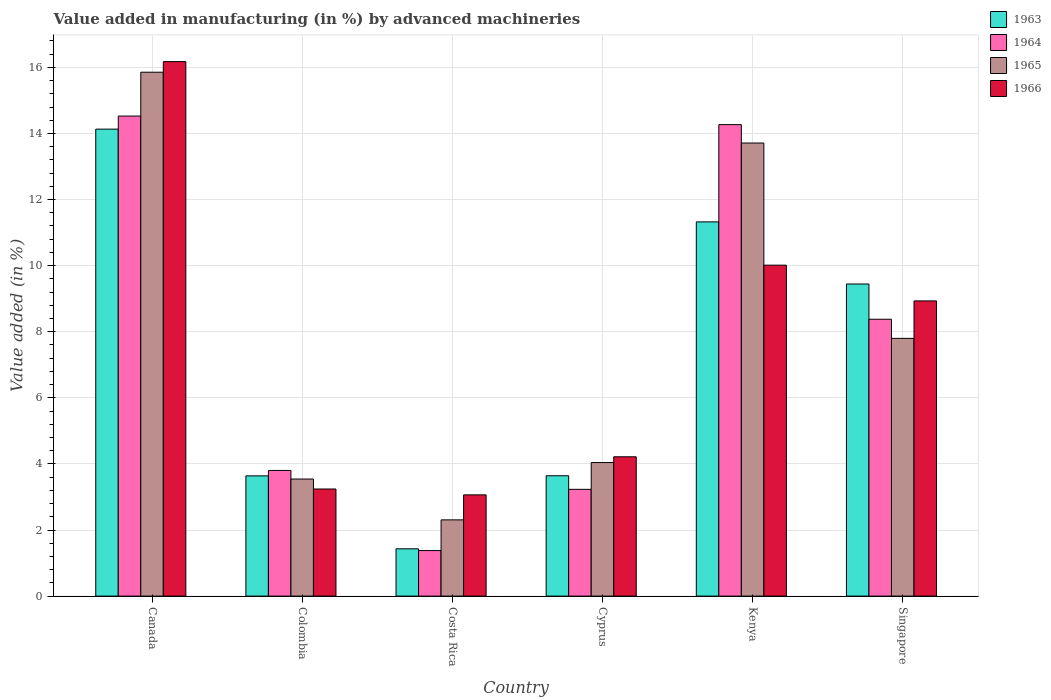How many different coloured bars are there?
Your answer should be compact. 4. How many groups of bars are there?
Your response must be concise. 6. Are the number of bars per tick equal to the number of legend labels?
Make the answer very short. Yes. What is the percentage of value added in manufacturing by advanced machineries in 1966 in Colombia?
Give a very brief answer. 3.24. Across all countries, what is the maximum percentage of value added in manufacturing by advanced machineries in 1964?
Give a very brief answer. 14.53. Across all countries, what is the minimum percentage of value added in manufacturing by advanced machineries in 1966?
Provide a succinct answer. 3.06. In which country was the percentage of value added in manufacturing by advanced machineries in 1963 maximum?
Provide a succinct answer. Canada. In which country was the percentage of value added in manufacturing by advanced machineries in 1965 minimum?
Your response must be concise. Costa Rica. What is the total percentage of value added in manufacturing by advanced machineries in 1965 in the graph?
Your response must be concise. 47.25. What is the difference between the percentage of value added in manufacturing by advanced machineries in 1965 in Canada and that in Singapore?
Make the answer very short. 8.05. What is the difference between the percentage of value added in manufacturing by advanced machineries in 1963 in Canada and the percentage of value added in manufacturing by advanced machineries in 1966 in Costa Rica?
Keep it short and to the point. 11.07. What is the average percentage of value added in manufacturing by advanced machineries in 1963 per country?
Give a very brief answer. 7.27. What is the difference between the percentage of value added in manufacturing by advanced machineries of/in 1964 and percentage of value added in manufacturing by advanced machineries of/in 1963 in Costa Rica?
Your answer should be very brief. -0.05. In how many countries, is the percentage of value added in manufacturing by advanced machineries in 1964 greater than 2.8 %?
Give a very brief answer. 5. What is the ratio of the percentage of value added in manufacturing by advanced machineries in 1964 in Canada to that in Kenya?
Keep it short and to the point. 1.02. Is the difference between the percentage of value added in manufacturing by advanced machineries in 1964 in Colombia and Costa Rica greater than the difference between the percentage of value added in manufacturing by advanced machineries in 1963 in Colombia and Costa Rica?
Your answer should be compact. Yes. What is the difference between the highest and the second highest percentage of value added in manufacturing by advanced machineries in 1963?
Give a very brief answer. -1.88. What is the difference between the highest and the lowest percentage of value added in manufacturing by advanced machineries in 1964?
Your answer should be very brief. 13.15. Is the sum of the percentage of value added in manufacturing by advanced machineries in 1966 in Kenya and Singapore greater than the maximum percentage of value added in manufacturing by advanced machineries in 1963 across all countries?
Keep it short and to the point. Yes. Is it the case that in every country, the sum of the percentage of value added in manufacturing by advanced machineries in 1966 and percentage of value added in manufacturing by advanced machineries in 1965 is greater than the sum of percentage of value added in manufacturing by advanced machineries in 1964 and percentage of value added in manufacturing by advanced machineries in 1963?
Your answer should be compact. Yes. What does the 3rd bar from the left in Canada represents?
Provide a short and direct response. 1965. What does the 2nd bar from the right in Canada represents?
Give a very brief answer. 1965. How many bars are there?
Provide a succinct answer. 24. Are all the bars in the graph horizontal?
Your answer should be compact. No. What is the difference between two consecutive major ticks on the Y-axis?
Give a very brief answer. 2. Does the graph contain any zero values?
Make the answer very short. No. Does the graph contain grids?
Give a very brief answer. Yes. Where does the legend appear in the graph?
Provide a short and direct response. Top right. What is the title of the graph?
Keep it short and to the point. Value added in manufacturing (in %) by advanced machineries. What is the label or title of the Y-axis?
Provide a succinct answer. Value added (in %). What is the Value added (in %) in 1963 in Canada?
Provide a succinct answer. 14.13. What is the Value added (in %) of 1964 in Canada?
Make the answer very short. 14.53. What is the Value added (in %) in 1965 in Canada?
Your answer should be compact. 15.85. What is the Value added (in %) in 1966 in Canada?
Give a very brief answer. 16.17. What is the Value added (in %) of 1963 in Colombia?
Ensure brevity in your answer.  3.64. What is the Value added (in %) in 1964 in Colombia?
Ensure brevity in your answer.  3.8. What is the Value added (in %) of 1965 in Colombia?
Your response must be concise. 3.54. What is the Value added (in %) of 1966 in Colombia?
Offer a terse response. 3.24. What is the Value added (in %) of 1963 in Costa Rica?
Provide a short and direct response. 1.43. What is the Value added (in %) of 1964 in Costa Rica?
Keep it short and to the point. 1.38. What is the Value added (in %) of 1965 in Costa Rica?
Keep it short and to the point. 2.31. What is the Value added (in %) of 1966 in Costa Rica?
Your response must be concise. 3.06. What is the Value added (in %) of 1963 in Cyprus?
Offer a terse response. 3.64. What is the Value added (in %) in 1964 in Cyprus?
Offer a very short reply. 3.23. What is the Value added (in %) of 1965 in Cyprus?
Your answer should be compact. 4.04. What is the Value added (in %) in 1966 in Cyprus?
Keep it short and to the point. 4.22. What is the Value added (in %) of 1963 in Kenya?
Provide a short and direct response. 11.32. What is the Value added (in %) of 1964 in Kenya?
Offer a very short reply. 14.27. What is the Value added (in %) of 1965 in Kenya?
Your answer should be compact. 13.71. What is the Value added (in %) in 1966 in Kenya?
Make the answer very short. 10.01. What is the Value added (in %) of 1963 in Singapore?
Your answer should be very brief. 9.44. What is the Value added (in %) in 1964 in Singapore?
Give a very brief answer. 8.38. What is the Value added (in %) in 1965 in Singapore?
Provide a succinct answer. 7.8. What is the Value added (in %) in 1966 in Singapore?
Offer a terse response. 8.93. Across all countries, what is the maximum Value added (in %) of 1963?
Give a very brief answer. 14.13. Across all countries, what is the maximum Value added (in %) of 1964?
Provide a short and direct response. 14.53. Across all countries, what is the maximum Value added (in %) of 1965?
Give a very brief answer. 15.85. Across all countries, what is the maximum Value added (in %) in 1966?
Keep it short and to the point. 16.17. Across all countries, what is the minimum Value added (in %) in 1963?
Provide a succinct answer. 1.43. Across all countries, what is the minimum Value added (in %) of 1964?
Your answer should be compact. 1.38. Across all countries, what is the minimum Value added (in %) in 1965?
Provide a succinct answer. 2.31. Across all countries, what is the minimum Value added (in %) of 1966?
Your answer should be very brief. 3.06. What is the total Value added (in %) in 1963 in the graph?
Give a very brief answer. 43.61. What is the total Value added (in %) of 1964 in the graph?
Give a very brief answer. 45.58. What is the total Value added (in %) in 1965 in the graph?
Ensure brevity in your answer.  47.25. What is the total Value added (in %) in 1966 in the graph?
Make the answer very short. 45.64. What is the difference between the Value added (in %) of 1963 in Canada and that in Colombia?
Keep it short and to the point. 10.49. What is the difference between the Value added (in %) of 1964 in Canada and that in Colombia?
Ensure brevity in your answer.  10.72. What is the difference between the Value added (in %) of 1965 in Canada and that in Colombia?
Give a very brief answer. 12.31. What is the difference between the Value added (in %) of 1966 in Canada and that in Colombia?
Ensure brevity in your answer.  12.93. What is the difference between the Value added (in %) of 1963 in Canada and that in Costa Rica?
Make the answer very short. 12.7. What is the difference between the Value added (in %) in 1964 in Canada and that in Costa Rica?
Make the answer very short. 13.15. What is the difference between the Value added (in %) of 1965 in Canada and that in Costa Rica?
Provide a short and direct response. 13.55. What is the difference between the Value added (in %) of 1966 in Canada and that in Costa Rica?
Your answer should be compact. 13.11. What is the difference between the Value added (in %) in 1963 in Canada and that in Cyprus?
Keep it short and to the point. 10.49. What is the difference between the Value added (in %) in 1964 in Canada and that in Cyprus?
Your answer should be compact. 11.3. What is the difference between the Value added (in %) of 1965 in Canada and that in Cyprus?
Keep it short and to the point. 11.81. What is the difference between the Value added (in %) of 1966 in Canada and that in Cyprus?
Give a very brief answer. 11.96. What is the difference between the Value added (in %) in 1963 in Canada and that in Kenya?
Your answer should be compact. 2.81. What is the difference between the Value added (in %) of 1964 in Canada and that in Kenya?
Your answer should be compact. 0.26. What is the difference between the Value added (in %) of 1965 in Canada and that in Kenya?
Offer a terse response. 2.14. What is the difference between the Value added (in %) in 1966 in Canada and that in Kenya?
Give a very brief answer. 6.16. What is the difference between the Value added (in %) in 1963 in Canada and that in Singapore?
Keep it short and to the point. 4.69. What is the difference between the Value added (in %) in 1964 in Canada and that in Singapore?
Your answer should be very brief. 6.15. What is the difference between the Value added (in %) of 1965 in Canada and that in Singapore?
Offer a very short reply. 8.05. What is the difference between the Value added (in %) in 1966 in Canada and that in Singapore?
Provide a short and direct response. 7.24. What is the difference between the Value added (in %) of 1963 in Colombia and that in Costa Rica?
Keep it short and to the point. 2.21. What is the difference between the Value added (in %) in 1964 in Colombia and that in Costa Rica?
Offer a very short reply. 2.42. What is the difference between the Value added (in %) in 1965 in Colombia and that in Costa Rica?
Give a very brief answer. 1.24. What is the difference between the Value added (in %) in 1966 in Colombia and that in Costa Rica?
Provide a succinct answer. 0.18. What is the difference between the Value added (in %) in 1963 in Colombia and that in Cyprus?
Give a very brief answer. -0. What is the difference between the Value added (in %) in 1964 in Colombia and that in Cyprus?
Your answer should be very brief. 0.57. What is the difference between the Value added (in %) of 1965 in Colombia and that in Cyprus?
Ensure brevity in your answer.  -0.5. What is the difference between the Value added (in %) of 1966 in Colombia and that in Cyprus?
Ensure brevity in your answer.  -0.97. What is the difference between the Value added (in %) in 1963 in Colombia and that in Kenya?
Offer a very short reply. -7.69. What is the difference between the Value added (in %) of 1964 in Colombia and that in Kenya?
Your answer should be very brief. -10.47. What is the difference between the Value added (in %) in 1965 in Colombia and that in Kenya?
Your answer should be compact. -10.17. What is the difference between the Value added (in %) in 1966 in Colombia and that in Kenya?
Make the answer very short. -6.77. What is the difference between the Value added (in %) in 1963 in Colombia and that in Singapore?
Keep it short and to the point. -5.81. What is the difference between the Value added (in %) of 1964 in Colombia and that in Singapore?
Make the answer very short. -4.58. What is the difference between the Value added (in %) in 1965 in Colombia and that in Singapore?
Give a very brief answer. -4.26. What is the difference between the Value added (in %) of 1966 in Colombia and that in Singapore?
Keep it short and to the point. -5.69. What is the difference between the Value added (in %) in 1963 in Costa Rica and that in Cyprus?
Offer a terse response. -2.21. What is the difference between the Value added (in %) of 1964 in Costa Rica and that in Cyprus?
Provide a succinct answer. -1.85. What is the difference between the Value added (in %) of 1965 in Costa Rica and that in Cyprus?
Your answer should be very brief. -1.73. What is the difference between the Value added (in %) in 1966 in Costa Rica and that in Cyprus?
Your response must be concise. -1.15. What is the difference between the Value added (in %) of 1963 in Costa Rica and that in Kenya?
Give a very brief answer. -9.89. What is the difference between the Value added (in %) in 1964 in Costa Rica and that in Kenya?
Keep it short and to the point. -12.89. What is the difference between the Value added (in %) of 1965 in Costa Rica and that in Kenya?
Your response must be concise. -11.4. What is the difference between the Value added (in %) in 1966 in Costa Rica and that in Kenya?
Provide a succinct answer. -6.95. What is the difference between the Value added (in %) of 1963 in Costa Rica and that in Singapore?
Keep it short and to the point. -8.01. What is the difference between the Value added (in %) of 1964 in Costa Rica and that in Singapore?
Your answer should be compact. -7. What is the difference between the Value added (in %) of 1965 in Costa Rica and that in Singapore?
Provide a succinct answer. -5.49. What is the difference between the Value added (in %) in 1966 in Costa Rica and that in Singapore?
Provide a short and direct response. -5.87. What is the difference between the Value added (in %) of 1963 in Cyprus and that in Kenya?
Your answer should be very brief. -7.68. What is the difference between the Value added (in %) of 1964 in Cyprus and that in Kenya?
Ensure brevity in your answer.  -11.04. What is the difference between the Value added (in %) of 1965 in Cyprus and that in Kenya?
Ensure brevity in your answer.  -9.67. What is the difference between the Value added (in %) of 1966 in Cyprus and that in Kenya?
Offer a terse response. -5.8. What is the difference between the Value added (in %) of 1963 in Cyprus and that in Singapore?
Keep it short and to the point. -5.8. What is the difference between the Value added (in %) of 1964 in Cyprus and that in Singapore?
Your answer should be very brief. -5.15. What is the difference between the Value added (in %) in 1965 in Cyprus and that in Singapore?
Make the answer very short. -3.76. What is the difference between the Value added (in %) of 1966 in Cyprus and that in Singapore?
Keep it short and to the point. -4.72. What is the difference between the Value added (in %) of 1963 in Kenya and that in Singapore?
Offer a terse response. 1.88. What is the difference between the Value added (in %) of 1964 in Kenya and that in Singapore?
Keep it short and to the point. 5.89. What is the difference between the Value added (in %) in 1965 in Kenya and that in Singapore?
Your response must be concise. 5.91. What is the difference between the Value added (in %) in 1966 in Kenya and that in Singapore?
Offer a terse response. 1.08. What is the difference between the Value added (in %) in 1963 in Canada and the Value added (in %) in 1964 in Colombia?
Your response must be concise. 10.33. What is the difference between the Value added (in %) of 1963 in Canada and the Value added (in %) of 1965 in Colombia?
Your response must be concise. 10.59. What is the difference between the Value added (in %) in 1963 in Canada and the Value added (in %) in 1966 in Colombia?
Ensure brevity in your answer.  10.89. What is the difference between the Value added (in %) of 1964 in Canada and the Value added (in %) of 1965 in Colombia?
Ensure brevity in your answer.  10.98. What is the difference between the Value added (in %) in 1964 in Canada and the Value added (in %) in 1966 in Colombia?
Provide a succinct answer. 11.29. What is the difference between the Value added (in %) of 1965 in Canada and the Value added (in %) of 1966 in Colombia?
Make the answer very short. 12.61. What is the difference between the Value added (in %) of 1963 in Canada and the Value added (in %) of 1964 in Costa Rica?
Ensure brevity in your answer.  12.75. What is the difference between the Value added (in %) in 1963 in Canada and the Value added (in %) in 1965 in Costa Rica?
Ensure brevity in your answer.  11.82. What is the difference between the Value added (in %) in 1963 in Canada and the Value added (in %) in 1966 in Costa Rica?
Your answer should be compact. 11.07. What is the difference between the Value added (in %) of 1964 in Canada and the Value added (in %) of 1965 in Costa Rica?
Your answer should be very brief. 12.22. What is the difference between the Value added (in %) in 1964 in Canada and the Value added (in %) in 1966 in Costa Rica?
Make the answer very short. 11.46. What is the difference between the Value added (in %) in 1965 in Canada and the Value added (in %) in 1966 in Costa Rica?
Keep it short and to the point. 12.79. What is the difference between the Value added (in %) in 1963 in Canada and the Value added (in %) in 1964 in Cyprus?
Ensure brevity in your answer.  10.9. What is the difference between the Value added (in %) in 1963 in Canada and the Value added (in %) in 1965 in Cyprus?
Give a very brief answer. 10.09. What is the difference between the Value added (in %) in 1963 in Canada and the Value added (in %) in 1966 in Cyprus?
Your answer should be very brief. 9.92. What is the difference between the Value added (in %) in 1964 in Canada and the Value added (in %) in 1965 in Cyprus?
Give a very brief answer. 10.49. What is the difference between the Value added (in %) of 1964 in Canada and the Value added (in %) of 1966 in Cyprus?
Your answer should be compact. 10.31. What is the difference between the Value added (in %) in 1965 in Canada and the Value added (in %) in 1966 in Cyprus?
Offer a terse response. 11.64. What is the difference between the Value added (in %) in 1963 in Canada and the Value added (in %) in 1964 in Kenya?
Your response must be concise. -0.14. What is the difference between the Value added (in %) of 1963 in Canada and the Value added (in %) of 1965 in Kenya?
Your answer should be very brief. 0.42. What is the difference between the Value added (in %) of 1963 in Canada and the Value added (in %) of 1966 in Kenya?
Provide a short and direct response. 4.12. What is the difference between the Value added (in %) in 1964 in Canada and the Value added (in %) in 1965 in Kenya?
Provide a short and direct response. 0.82. What is the difference between the Value added (in %) in 1964 in Canada and the Value added (in %) in 1966 in Kenya?
Your response must be concise. 4.51. What is the difference between the Value added (in %) of 1965 in Canada and the Value added (in %) of 1966 in Kenya?
Offer a very short reply. 5.84. What is the difference between the Value added (in %) in 1963 in Canada and the Value added (in %) in 1964 in Singapore?
Your answer should be very brief. 5.75. What is the difference between the Value added (in %) in 1963 in Canada and the Value added (in %) in 1965 in Singapore?
Offer a very short reply. 6.33. What is the difference between the Value added (in %) in 1963 in Canada and the Value added (in %) in 1966 in Singapore?
Provide a succinct answer. 5.2. What is the difference between the Value added (in %) of 1964 in Canada and the Value added (in %) of 1965 in Singapore?
Make the answer very short. 6.73. What is the difference between the Value added (in %) of 1964 in Canada and the Value added (in %) of 1966 in Singapore?
Provide a succinct answer. 5.59. What is the difference between the Value added (in %) in 1965 in Canada and the Value added (in %) in 1966 in Singapore?
Offer a terse response. 6.92. What is the difference between the Value added (in %) in 1963 in Colombia and the Value added (in %) in 1964 in Costa Rica?
Your answer should be compact. 2.26. What is the difference between the Value added (in %) of 1963 in Colombia and the Value added (in %) of 1965 in Costa Rica?
Your answer should be very brief. 1.33. What is the difference between the Value added (in %) in 1963 in Colombia and the Value added (in %) in 1966 in Costa Rica?
Your answer should be compact. 0.57. What is the difference between the Value added (in %) of 1964 in Colombia and the Value added (in %) of 1965 in Costa Rica?
Ensure brevity in your answer.  1.49. What is the difference between the Value added (in %) of 1964 in Colombia and the Value added (in %) of 1966 in Costa Rica?
Keep it short and to the point. 0.74. What is the difference between the Value added (in %) of 1965 in Colombia and the Value added (in %) of 1966 in Costa Rica?
Your answer should be very brief. 0.48. What is the difference between the Value added (in %) in 1963 in Colombia and the Value added (in %) in 1964 in Cyprus?
Offer a terse response. 0.41. What is the difference between the Value added (in %) of 1963 in Colombia and the Value added (in %) of 1965 in Cyprus?
Give a very brief answer. -0.4. What is the difference between the Value added (in %) of 1963 in Colombia and the Value added (in %) of 1966 in Cyprus?
Your response must be concise. -0.58. What is the difference between the Value added (in %) in 1964 in Colombia and the Value added (in %) in 1965 in Cyprus?
Give a very brief answer. -0.24. What is the difference between the Value added (in %) of 1964 in Colombia and the Value added (in %) of 1966 in Cyprus?
Offer a terse response. -0.41. What is the difference between the Value added (in %) of 1965 in Colombia and the Value added (in %) of 1966 in Cyprus?
Offer a very short reply. -0.67. What is the difference between the Value added (in %) of 1963 in Colombia and the Value added (in %) of 1964 in Kenya?
Keep it short and to the point. -10.63. What is the difference between the Value added (in %) in 1963 in Colombia and the Value added (in %) in 1965 in Kenya?
Make the answer very short. -10.07. What is the difference between the Value added (in %) in 1963 in Colombia and the Value added (in %) in 1966 in Kenya?
Provide a succinct answer. -6.38. What is the difference between the Value added (in %) in 1964 in Colombia and the Value added (in %) in 1965 in Kenya?
Your answer should be compact. -9.91. What is the difference between the Value added (in %) in 1964 in Colombia and the Value added (in %) in 1966 in Kenya?
Offer a terse response. -6.21. What is the difference between the Value added (in %) in 1965 in Colombia and the Value added (in %) in 1966 in Kenya?
Make the answer very short. -6.47. What is the difference between the Value added (in %) of 1963 in Colombia and the Value added (in %) of 1964 in Singapore?
Your answer should be compact. -4.74. What is the difference between the Value added (in %) in 1963 in Colombia and the Value added (in %) in 1965 in Singapore?
Make the answer very short. -4.16. What is the difference between the Value added (in %) in 1963 in Colombia and the Value added (in %) in 1966 in Singapore?
Make the answer very short. -5.29. What is the difference between the Value added (in %) in 1964 in Colombia and the Value added (in %) in 1965 in Singapore?
Offer a terse response. -4. What is the difference between the Value added (in %) of 1964 in Colombia and the Value added (in %) of 1966 in Singapore?
Provide a succinct answer. -5.13. What is the difference between the Value added (in %) of 1965 in Colombia and the Value added (in %) of 1966 in Singapore?
Keep it short and to the point. -5.39. What is the difference between the Value added (in %) in 1963 in Costa Rica and the Value added (in %) in 1964 in Cyprus?
Provide a succinct answer. -1.8. What is the difference between the Value added (in %) of 1963 in Costa Rica and the Value added (in %) of 1965 in Cyprus?
Offer a very short reply. -2.61. What is the difference between the Value added (in %) in 1963 in Costa Rica and the Value added (in %) in 1966 in Cyprus?
Make the answer very short. -2.78. What is the difference between the Value added (in %) of 1964 in Costa Rica and the Value added (in %) of 1965 in Cyprus?
Offer a very short reply. -2.66. What is the difference between the Value added (in %) of 1964 in Costa Rica and the Value added (in %) of 1966 in Cyprus?
Provide a short and direct response. -2.84. What is the difference between the Value added (in %) of 1965 in Costa Rica and the Value added (in %) of 1966 in Cyprus?
Offer a terse response. -1.91. What is the difference between the Value added (in %) of 1963 in Costa Rica and the Value added (in %) of 1964 in Kenya?
Make the answer very short. -12.84. What is the difference between the Value added (in %) of 1963 in Costa Rica and the Value added (in %) of 1965 in Kenya?
Your answer should be compact. -12.28. What is the difference between the Value added (in %) of 1963 in Costa Rica and the Value added (in %) of 1966 in Kenya?
Your answer should be very brief. -8.58. What is the difference between the Value added (in %) in 1964 in Costa Rica and the Value added (in %) in 1965 in Kenya?
Give a very brief answer. -12.33. What is the difference between the Value added (in %) in 1964 in Costa Rica and the Value added (in %) in 1966 in Kenya?
Ensure brevity in your answer.  -8.64. What is the difference between the Value added (in %) of 1965 in Costa Rica and the Value added (in %) of 1966 in Kenya?
Your answer should be compact. -7.71. What is the difference between the Value added (in %) of 1963 in Costa Rica and the Value added (in %) of 1964 in Singapore?
Provide a succinct answer. -6.95. What is the difference between the Value added (in %) in 1963 in Costa Rica and the Value added (in %) in 1965 in Singapore?
Your answer should be very brief. -6.37. What is the difference between the Value added (in %) of 1963 in Costa Rica and the Value added (in %) of 1966 in Singapore?
Offer a terse response. -7.5. What is the difference between the Value added (in %) in 1964 in Costa Rica and the Value added (in %) in 1965 in Singapore?
Your response must be concise. -6.42. What is the difference between the Value added (in %) in 1964 in Costa Rica and the Value added (in %) in 1966 in Singapore?
Give a very brief answer. -7.55. What is the difference between the Value added (in %) of 1965 in Costa Rica and the Value added (in %) of 1966 in Singapore?
Provide a short and direct response. -6.63. What is the difference between the Value added (in %) in 1963 in Cyprus and the Value added (in %) in 1964 in Kenya?
Keep it short and to the point. -10.63. What is the difference between the Value added (in %) of 1963 in Cyprus and the Value added (in %) of 1965 in Kenya?
Ensure brevity in your answer.  -10.07. What is the difference between the Value added (in %) of 1963 in Cyprus and the Value added (in %) of 1966 in Kenya?
Your answer should be compact. -6.37. What is the difference between the Value added (in %) of 1964 in Cyprus and the Value added (in %) of 1965 in Kenya?
Provide a short and direct response. -10.48. What is the difference between the Value added (in %) in 1964 in Cyprus and the Value added (in %) in 1966 in Kenya?
Provide a short and direct response. -6.78. What is the difference between the Value added (in %) in 1965 in Cyprus and the Value added (in %) in 1966 in Kenya?
Keep it short and to the point. -5.97. What is the difference between the Value added (in %) of 1963 in Cyprus and the Value added (in %) of 1964 in Singapore?
Provide a succinct answer. -4.74. What is the difference between the Value added (in %) of 1963 in Cyprus and the Value added (in %) of 1965 in Singapore?
Offer a very short reply. -4.16. What is the difference between the Value added (in %) in 1963 in Cyprus and the Value added (in %) in 1966 in Singapore?
Give a very brief answer. -5.29. What is the difference between the Value added (in %) of 1964 in Cyprus and the Value added (in %) of 1965 in Singapore?
Ensure brevity in your answer.  -4.57. What is the difference between the Value added (in %) of 1964 in Cyprus and the Value added (in %) of 1966 in Singapore?
Your response must be concise. -5.7. What is the difference between the Value added (in %) in 1965 in Cyprus and the Value added (in %) in 1966 in Singapore?
Keep it short and to the point. -4.89. What is the difference between the Value added (in %) in 1963 in Kenya and the Value added (in %) in 1964 in Singapore?
Ensure brevity in your answer.  2.95. What is the difference between the Value added (in %) of 1963 in Kenya and the Value added (in %) of 1965 in Singapore?
Offer a terse response. 3.52. What is the difference between the Value added (in %) in 1963 in Kenya and the Value added (in %) in 1966 in Singapore?
Offer a very short reply. 2.39. What is the difference between the Value added (in %) in 1964 in Kenya and the Value added (in %) in 1965 in Singapore?
Keep it short and to the point. 6.47. What is the difference between the Value added (in %) of 1964 in Kenya and the Value added (in %) of 1966 in Singapore?
Your response must be concise. 5.33. What is the difference between the Value added (in %) of 1965 in Kenya and the Value added (in %) of 1966 in Singapore?
Make the answer very short. 4.78. What is the average Value added (in %) in 1963 per country?
Keep it short and to the point. 7.27. What is the average Value added (in %) of 1964 per country?
Give a very brief answer. 7.6. What is the average Value added (in %) in 1965 per country?
Provide a succinct answer. 7.88. What is the average Value added (in %) in 1966 per country?
Provide a succinct answer. 7.61. What is the difference between the Value added (in %) of 1963 and Value added (in %) of 1964 in Canada?
Give a very brief answer. -0.4. What is the difference between the Value added (in %) in 1963 and Value added (in %) in 1965 in Canada?
Offer a very short reply. -1.72. What is the difference between the Value added (in %) in 1963 and Value added (in %) in 1966 in Canada?
Make the answer very short. -2.04. What is the difference between the Value added (in %) of 1964 and Value added (in %) of 1965 in Canada?
Offer a very short reply. -1.33. What is the difference between the Value added (in %) of 1964 and Value added (in %) of 1966 in Canada?
Ensure brevity in your answer.  -1.65. What is the difference between the Value added (in %) of 1965 and Value added (in %) of 1966 in Canada?
Ensure brevity in your answer.  -0.32. What is the difference between the Value added (in %) in 1963 and Value added (in %) in 1964 in Colombia?
Your answer should be very brief. -0.16. What is the difference between the Value added (in %) in 1963 and Value added (in %) in 1965 in Colombia?
Give a very brief answer. 0.1. What is the difference between the Value added (in %) in 1963 and Value added (in %) in 1966 in Colombia?
Your response must be concise. 0.4. What is the difference between the Value added (in %) of 1964 and Value added (in %) of 1965 in Colombia?
Provide a succinct answer. 0.26. What is the difference between the Value added (in %) in 1964 and Value added (in %) in 1966 in Colombia?
Your response must be concise. 0.56. What is the difference between the Value added (in %) in 1965 and Value added (in %) in 1966 in Colombia?
Your answer should be compact. 0.3. What is the difference between the Value added (in %) in 1963 and Value added (in %) in 1964 in Costa Rica?
Make the answer very short. 0.05. What is the difference between the Value added (in %) in 1963 and Value added (in %) in 1965 in Costa Rica?
Offer a very short reply. -0.88. What is the difference between the Value added (in %) of 1963 and Value added (in %) of 1966 in Costa Rica?
Provide a short and direct response. -1.63. What is the difference between the Value added (in %) in 1964 and Value added (in %) in 1965 in Costa Rica?
Your answer should be very brief. -0.93. What is the difference between the Value added (in %) in 1964 and Value added (in %) in 1966 in Costa Rica?
Give a very brief answer. -1.69. What is the difference between the Value added (in %) of 1965 and Value added (in %) of 1966 in Costa Rica?
Your answer should be very brief. -0.76. What is the difference between the Value added (in %) of 1963 and Value added (in %) of 1964 in Cyprus?
Offer a very short reply. 0.41. What is the difference between the Value added (in %) of 1963 and Value added (in %) of 1965 in Cyprus?
Your answer should be very brief. -0.4. What is the difference between the Value added (in %) of 1963 and Value added (in %) of 1966 in Cyprus?
Give a very brief answer. -0.57. What is the difference between the Value added (in %) in 1964 and Value added (in %) in 1965 in Cyprus?
Offer a very short reply. -0.81. What is the difference between the Value added (in %) in 1964 and Value added (in %) in 1966 in Cyprus?
Offer a terse response. -0.98. What is the difference between the Value added (in %) of 1965 and Value added (in %) of 1966 in Cyprus?
Offer a terse response. -0.17. What is the difference between the Value added (in %) in 1963 and Value added (in %) in 1964 in Kenya?
Provide a short and direct response. -2.94. What is the difference between the Value added (in %) of 1963 and Value added (in %) of 1965 in Kenya?
Ensure brevity in your answer.  -2.39. What is the difference between the Value added (in %) in 1963 and Value added (in %) in 1966 in Kenya?
Keep it short and to the point. 1.31. What is the difference between the Value added (in %) in 1964 and Value added (in %) in 1965 in Kenya?
Give a very brief answer. 0.56. What is the difference between the Value added (in %) in 1964 and Value added (in %) in 1966 in Kenya?
Make the answer very short. 4.25. What is the difference between the Value added (in %) of 1965 and Value added (in %) of 1966 in Kenya?
Provide a short and direct response. 3.7. What is the difference between the Value added (in %) of 1963 and Value added (in %) of 1964 in Singapore?
Ensure brevity in your answer.  1.07. What is the difference between the Value added (in %) of 1963 and Value added (in %) of 1965 in Singapore?
Ensure brevity in your answer.  1.64. What is the difference between the Value added (in %) of 1963 and Value added (in %) of 1966 in Singapore?
Your response must be concise. 0.51. What is the difference between the Value added (in %) of 1964 and Value added (in %) of 1965 in Singapore?
Provide a succinct answer. 0.58. What is the difference between the Value added (in %) in 1964 and Value added (in %) in 1966 in Singapore?
Your answer should be compact. -0.55. What is the difference between the Value added (in %) of 1965 and Value added (in %) of 1966 in Singapore?
Provide a succinct answer. -1.13. What is the ratio of the Value added (in %) in 1963 in Canada to that in Colombia?
Your response must be concise. 3.88. What is the ratio of the Value added (in %) in 1964 in Canada to that in Colombia?
Ensure brevity in your answer.  3.82. What is the ratio of the Value added (in %) of 1965 in Canada to that in Colombia?
Offer a very short reply. 4.48. What is the ratio of the Value added (in %) in 1966 in Canada to that in Colombia?
Provide a succinct answer. 4.99. What is the ratio of the Value added (in %) of 1963 in Canada to that in Costa Rica?
Your answer should be very brief. 9.87. What is the ratio of the Value added (in %) in 1964 in Canada to that in Costa Rica?
Offer a very short reply. 10.54. What is the ratio of the Value added (in %) of 1965 in Canada to that in Costa Rica?
Give a very brief answer. 6.87. What is the ratio of the Value added (in %) of 1966 in Canada to that in Costa Rica?
Your answer should be very brief. 5.28. What is the ratio of the Value added (in %) of 1963 in Canada to that in Cyprus?
Offer a very short reply. 3.88. What is the ratio of the Value added (in %) in 1964 in Canada to that in Cyprus?
Provide a succinct answer. 4.5. What is the ratio of the Value added (in %) in 1965 in Canada to that in Cyprus?
Keep it short and to the point. 3.92. What is the ratio of the Value added (in %) of 1966 in Canada to that in Cyprus?
Keep it short and to the point. 3.84. What is the ratio of the Value added (in %) in 1963 in Canada to that in Kenya?
Your answer should be very brief. 1.25. What is the ratio of the Value added (in %) in 1964 in Canada to that in Kenya?
Your answer should be compact. 1.02. What is the ratio of the Value added (in %) in 1965 in Canada to that in Kenya?
Ensure brevity in your answer.  1.16. What is the ratio of the Value added (in %) in 1966 in Canada to that in Kenya?
Provide a short and direct response. 1.62. What is the ratio of the Value added (in %) in 1963 in Canada to that in Singapore?
Your answer should be very brief. 1.5. What is the ratio of the Value added (in %) of 1964 in Canada to that in Singapore?
Make the answer very short. 1.73. What is the ratio of the Value added (in %) of 1965 in Canada to that in Singapore?
Provide a short and direct response. 2.03. What is the ratio of the Value added (in %) of 1966 in Canada to that in Singapore?
Provide a short and direct response. 1.81. What is the ratio of the Value added (in %) of 1963 in Colombia to that in Costa Rica?
Provide a short and direct response. 2.54. What is the ratio of the Value added (in %) in 1964 in Colombia to that in Costa Rica?
Your response must be concise. 2.76. What is the ratio of the Value added (in %) in 1965 in Colombia to that in Costa Rica?
Offer a very short reply. 1.54. What is the ratio of the Value added (in %) of 1966 in Colombia to that in Costa Rica?
Offer a terse response. 1.06. What is the ratio of the Value added (in %) of 1963 in Colombia to that in Cyprus?
Provide a short and direct response. 1. What is the ratio of the Value added (in %) of 1964 in Colombia to that in Cyprus?
Provide a succinct answer. 1.18. What is the ratio of the Value added (in %) of 1965 in Colombia to that in Cyprus?
Your response must be concise. 0.88. What is the ratio of the Value added (in %) of 1966 in Colombia to that in Cyprus?
Keep it short and to the point. 0.77. What is the ratio of the Value added (in %) in 1963 in Colombia to that in Kenya?
Provide a succinct answer. 0.32. What is the ratio of the Value added (in %) of 1964 in Colombia to that in Kenya?
Offer a terse response. 0.27. What is the ratio of the Value added (in %) in 1965 in Colombia to that in Kenya?
Make the answer very short. 0.26. What is the ratio of the Value added (in %) in 1966 in Colombia to that in Kenya?
Make the answer very short. 0.32. What is the ratio of the Value added (in %) in 1963 in Colombia to that in Singapore?
Provide a succinct answer. 0.39. What is the ratio of the Value added (in %) in 1964 in Colombia to that in Singapore?
Your answer should be compact. 0.45. What is the ratio of the Value added (in %) in 1965 in Colombia to that in Singapore?
Offer a very short reply. 0.45. What is the ratio of the Value added (in %) of 1966 in Colombia to that in Singapore?
Give a very brief answer. 0.36. What is the ratio of the Value added (in %) of 1963 in Costa Rica to that in Cyprus?
Make the answer very short. 0.39. What is the ratio of the Value added (in %) in 1964 in Costa Rica to that in Cyprus?
Your answer should be compact. 0.43. What is the ratio of the Value added (in %) in 1965 in Costa Rica to that in Cyprus?
Your response must be concise. 0.57. What is the ratio of the Value added (in %) in 1966 in Costa Rica to that in Cyprus?
Offer a very short reply. 0.73. What is the ratio of the Value added (in %) of 1963 in Costa Rica to that in Kenya?
Provide a short and direct response. 0.13. What is the ratio of the Value added (in %) of 1964 in Costa Rica to that in Kenya?
Give a very brief answer. 0.1. What is the ratio of the Value added (in %) in 1965 in Costa Rica to that in Kenya?
Ensure brevity in your answer.  0.17. What is the ratio of the Value added (in %) in 1966 in Costa Rica to that in Kenya?
Give a very brief answer. 0.31. What is the ratio of the Value added (in %) of 1963 in Costa Rica to that in Singapore?
Keep it short and to the point. 0.15. What is the ratio of the Value added (in %) in 1964 in Costa Rica to that in Singapore?
Offer a terse response. 0.16. What is the ratio of the Value added (in %) of 1965 in Costa Rica to that in Singapore?
Offer a terse response. 0.3. What is the ratio of the Value added (in %) in 1966 in Costa Rica to that in Singapore?
Your answer should be very brief. 0.34. What is the ratio of the Value added (in %) of 1963 in Cyprus to that in Kenya?
Provide a succinct answer. 0.32. What is the ratio of the Value added (in %) in 1964 in Cyprus to that in Kenya?
Provide a short and direct response. 0.23. What is the ratio of the Value added (in %) in 1965 in Cyprus to that in Kenya?
Give a very brief answer. 0.29. What is the ratio of the Value added (in %) in 1966 in Cyprus to that in Kenya?
Offer a terse response. 0.42. What is the ratio of the Value added (in %) of 1963 in Cyprus to that in Singapore?
Make the answer very short. 0.39. What is the ratio of the Value added (in %) in 1964 in Cyprus to that in Singapore?
Give a very brief answer. 0.39. What is the ratio of the Value added (in %) of 1965 in Cyprus to that in Singapore?
Offer a terse response. 0.52. What is the ratio of the Value added (in %) in 1966 in Cyprus to that in Singapore?
Ensure brevity in your answer.  0.47. What is the ratio of the Value added (in %) of 1963 in Kenya to that in Singapore?
Offer a terse response. 1.2. What is the ratio of the Value added (in %) of 1964 in Kenya to that in Singapore?
Keep it short and to the point. 1.7. What is the ratio of the Value added (in %) of 1965 in Kenya to that in Singapore?
Make the answer very short. 1.76. What is the ratio of the Value added (in %) in 1966 in Kenya to that in Singapore?
Make the answer very short. 1.12. What is the difference between the highest and the second highest Value added (in %) in 1963?
Ensure brevity in your answer.  2.81. What is the difference between the highest and the second highest Value added (in %) of 1964?
Your answer should be very brief. 0.26. What is the difference between the highest and the second highest Value added (in %) of 1965?
Make the answer very short. 2.14. What is the difference between the highest and the second highest Value added (in %) in 1966?
Make the answer very short. 6.16. What is the difference between the highest and the lowest Value added (in %) of 1963?
Offer a very short reply. 12.7. What is the difference between the highest and the lowest Value added (in %) of 1964?
Provide a succinct answer. 13.15. What is the difference between the highest and the lowest Value added (in %) in 1965?
Offer a terse response. 13.55. What is the difference between the highest and the lowest Value added (in %) of 1966?
Offer a terse response. 13.11. 